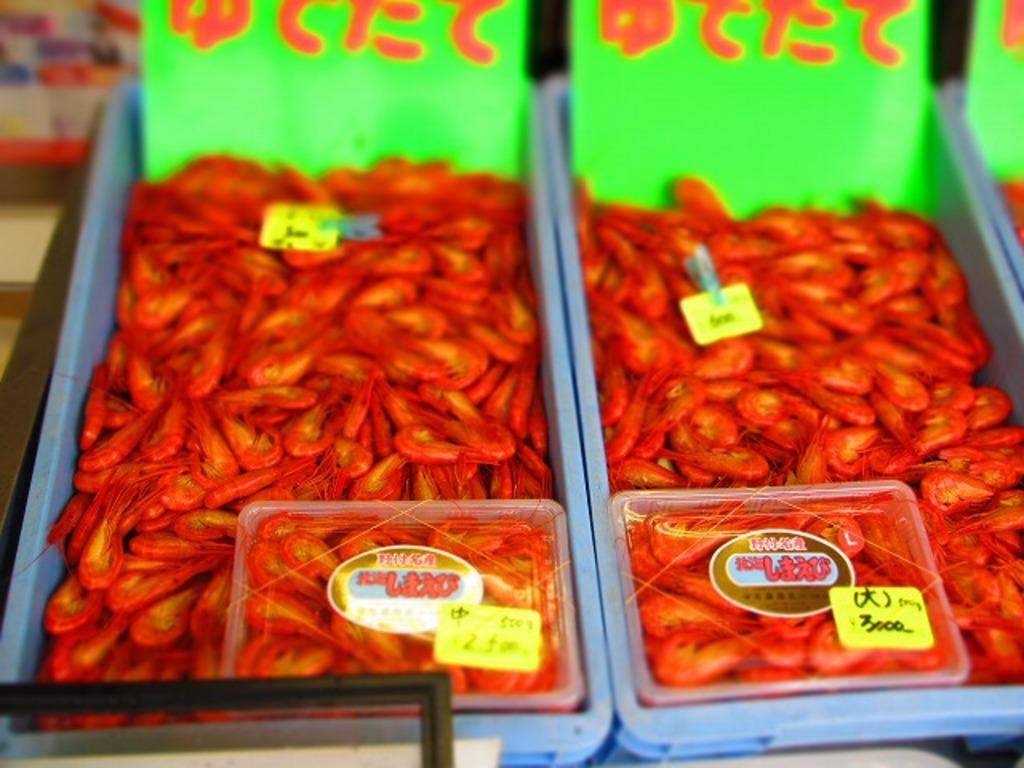What type of food item is visible in the image? There are dried prawns in the image. How are the dried prawns stored or displayed? The dried prawns are in containers. Are there any additional details about the containers in the image? Yes, the containers have price tags in the image. What type of destruction can be seen in the image? There is no destruction present in the image; it features containers of dried prawns with price tags. What route is visible in the image? There is no route visible in the image; it only shows containers of dried prawns with price tags. 